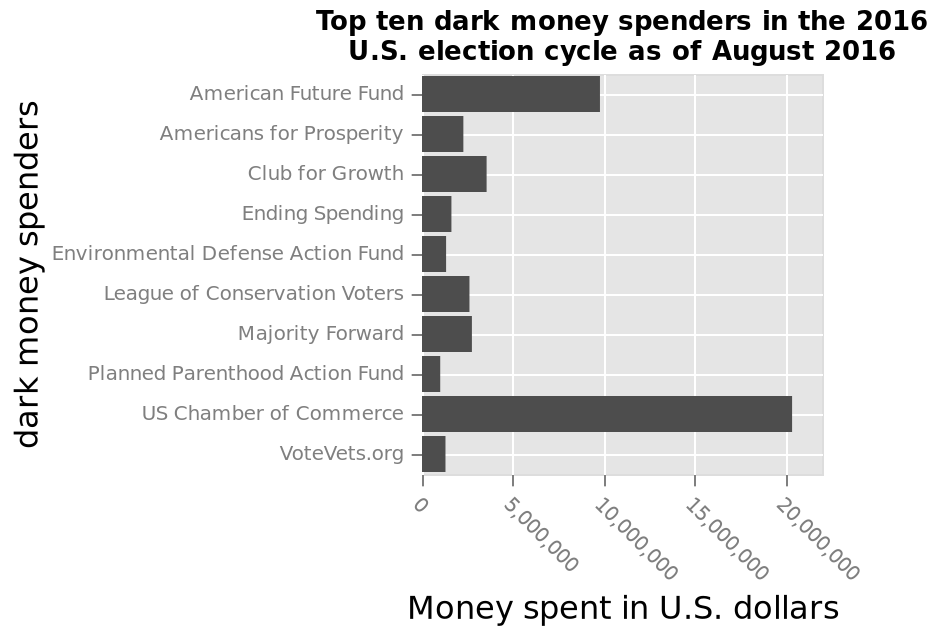<image>
How much dark money did the US chamber of commerce spend? The US chamber of commerce spent over 20,000,000 dollars as dark money. Which organization spent more, the US chamber of commerce or the American future fund? The US chamber of commerce spent more with over 20,000,000 dollars in dark money, while the American future fund spent just under 10,000,000. 